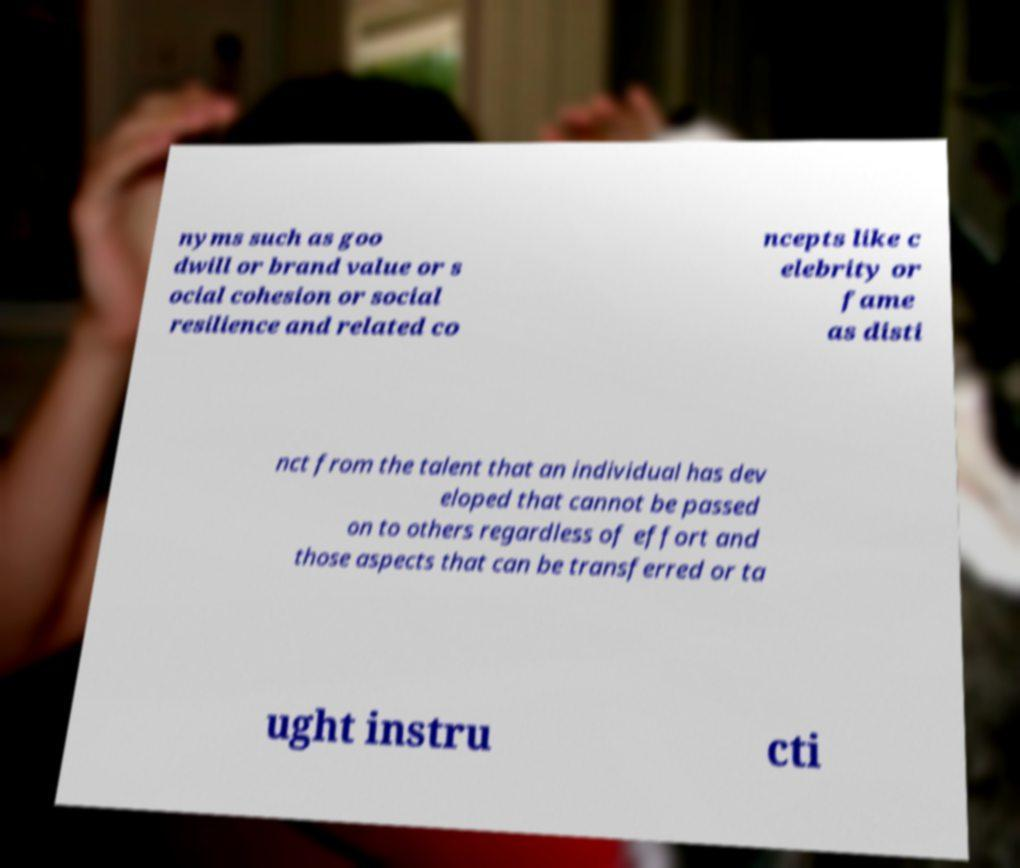Could you extract and type out the text from this image? nyms such as goo dwill or brand value or s ocial cohesion or social resilience and related co ncepts like c elebrity or fame as disti nct from the talent that an individual has dev eloped that cannot be passed on to others regardless of effort and those aspects that can be transferred or ta ught instru cti 